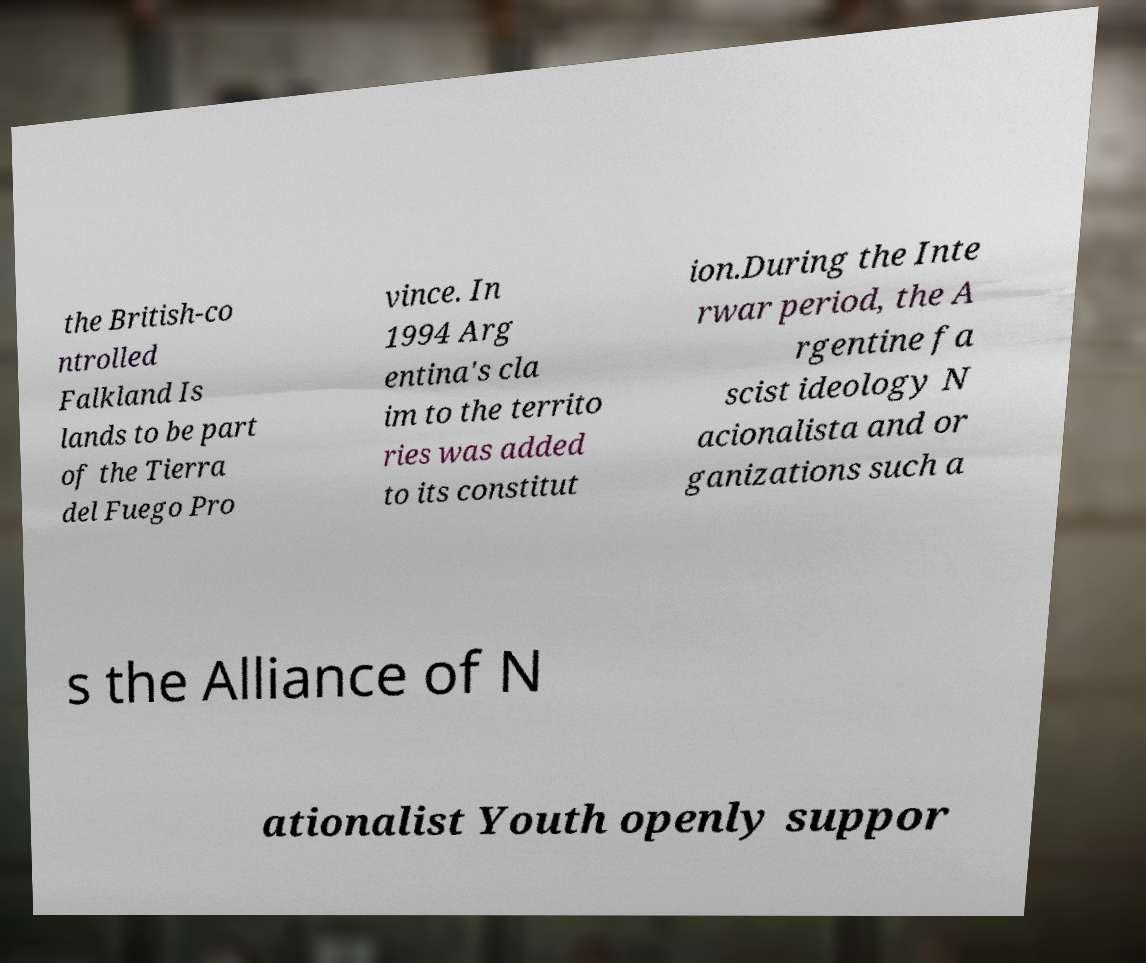Could you assist in decoding the text presented in this image and type it out clearly? the British-co ntrolled Falkland Is lands to be part of the Tierra del Fuego Pro vince. In 1994 Arg entina's cla im to the territo ries was added to its constitut ion.During the Inte rwar period, the A rgentine fa scist ideology N acionalista and or ganizations such a s the Alliance of N ationalist Youth openly suppor 